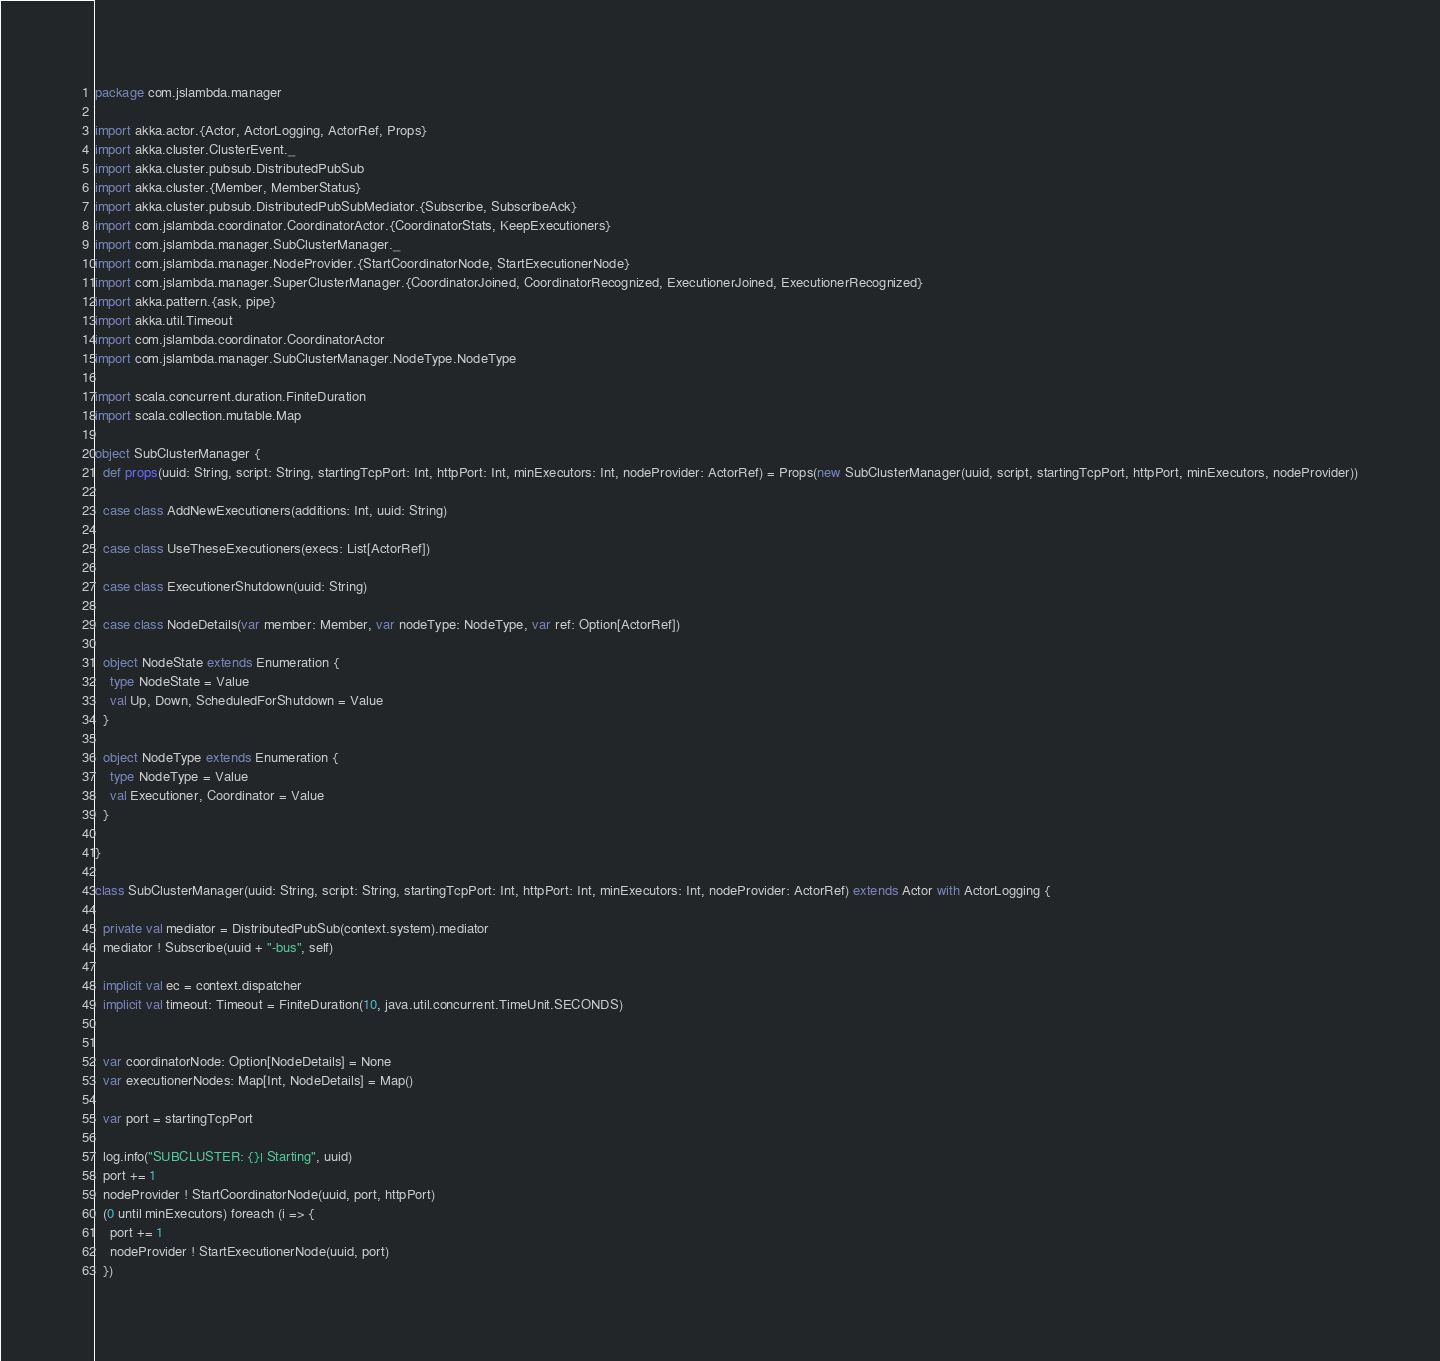<code> <loc_0><loc_0><loc_500><loc_500><_Scala_>package com.jslambda.manager

import akka.actor.{Actor, ActorLogging, ActorRef, Props}
import akka.cluster.ClusterEvent._
import akka.cluster.pubsub.DistributedPubSub
import akka.cluster.{Member, MemberStatus}
import akka.cluster.pubsub.DistributedPubSubMediator.{Subscribe, SubscribeAck}
import com.jslambda.coordinator.CoordinatorActor.{CoordinatorStats, KeepExecutioners}
import com.jslambda.manager.SubClusterManager._
import com.jslambda.manager.NodeProvider.{StartCoordinatorNode, StartExecutionerNode}
import com.jslambda.manager.SuperClusterManager.{CoordinatorJoined, CoordinatorRecognized, ExecutionerJoined, ExecutionerRecognized}
import akka.pattern.{ask, pipe}
import akka.util.Timeout
import com.jslambda.coordinator.CoordinatorActor
import com.jslambda.manager.SubClusterManager.NodeType.NodeType

import scala.concurrent.duration.FiniteDuration
import scala.collection.mutable.Map

object SubClusterManager {
  def props(uuid: String, script: String, startingTcpPort: Int, httpPort: Int, minExecutors: Int, nodeProvider: ActorRef) = Props(new SubClusterManager(uuid, script, startingTcpPort, httpPort, minExecutors, nodeProvider))

  case class AddNewExecutioners(additions: Int, uuid: String)

  case class UseTheseExecutioners(execs: List[ActorRef])

  case class ExecutionerShutdown(uuid: String)

  case class NodeDetails(var member: Member, var nodeType: NodeType, var ref: Option[ActorRef])

  object NodeState extends Enumeration {
    type NodeState = Value
    val Up, Down, ScheduledForShutdown = Value
  }

  object NodeType extends Enumeration {
    type NodeType = Value
    val Executioner, Coordinator = Value
  }

}

class SubClusterManager(uuid: String, script: String, startingTcpPort: Int, httpPort: Int, minExecutors: Int, nodeProvider: ActorRef) extends Actor with ActorLogging {

  private val mediator = DistributedPubSub(context.system).mediator
  mediator ! Subscribe(uuid + "-bus", self)

  implicit val ec = context.dispatcher
  implicit val timeout: Timeout = FiniteDuration(10, java.util.concurrent.TimeUnit.SECONDS)


  var coordinatorNode: Option[NodeDetails] = None
  var executionerNodes: Map[Int, NodeDetails] = Map()

  var port = startingTcpPort

  log.info("SUBCLUSTER: {}| Starting", uuid)
  port += 1
  nodeProvider ! StartCoordinatorNode(uuid, port, httpPort)
  (0 until minExecutors) foreach (i => {
    port += 1
    nodeProvider ! StartExecutionerNode(uuid, port)
  })
</code> 